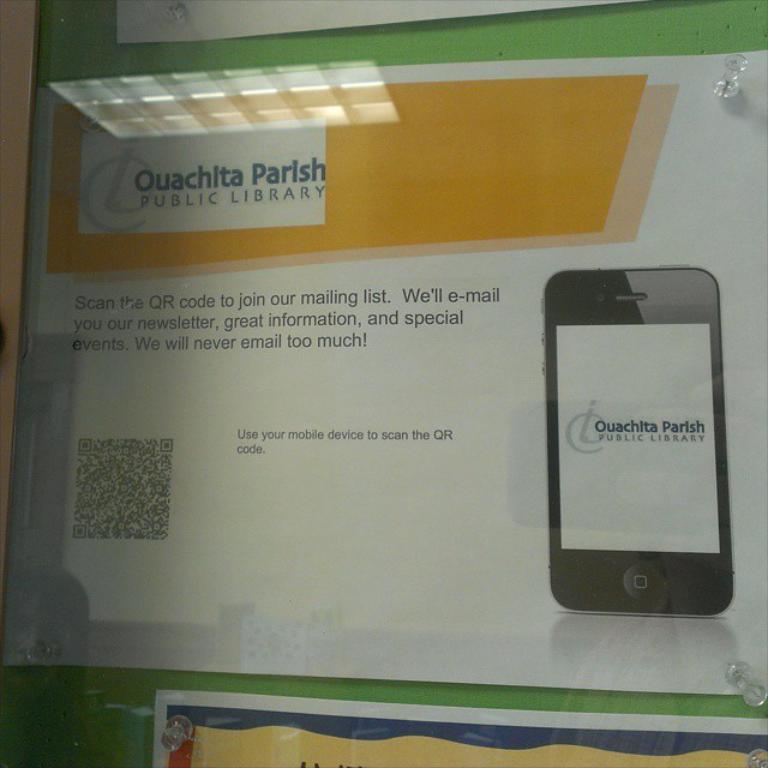How would you summarize this image in a sentence or two? In this image there are some posters are attached on the wall as we can see there is some text written on this posters and there is a picture of a mobile at right side of this image and there is a clip at top right corner of this image and left corner of this image as well. 